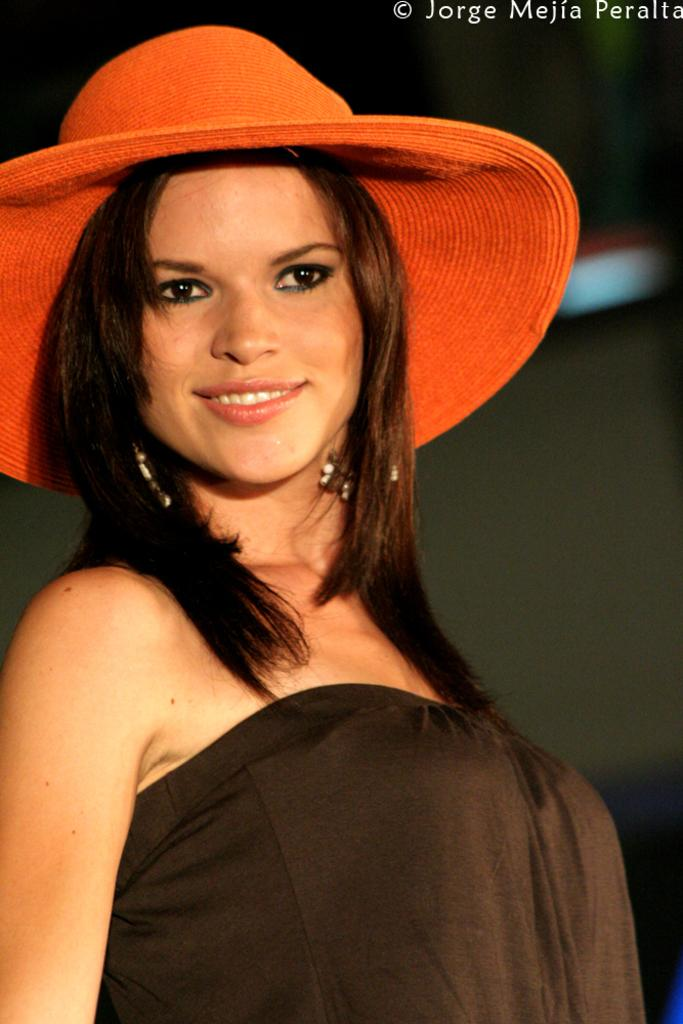What is the main subject of the image? The main subject of the image is a woman. What is the woman wearing on her head? The woman is wearing a hat. What type of ink is being used to write on the woman's hat in the image? There is no ink or writing present on the woman's hat in the image. 